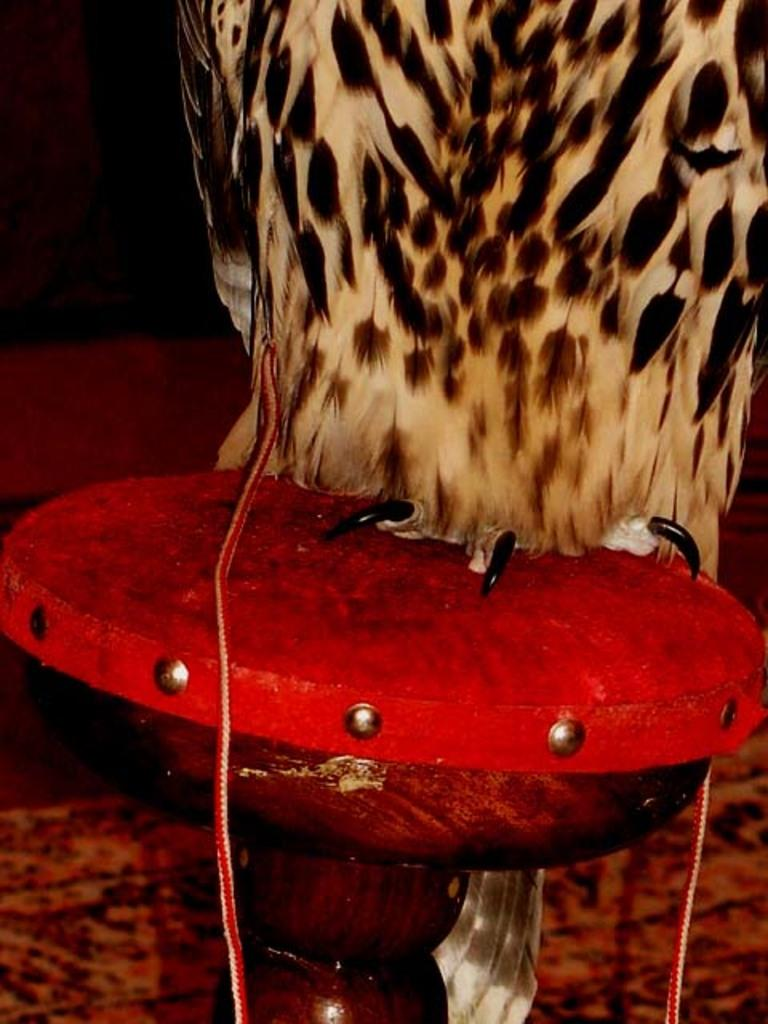What type of animal can be seen in the image? There is a bird in the image. Where is the bird located? The bird is on a stool. What can be observed about the background of the image? The background of the image is dark. How many dust particles can be seen on the bird in the image? There is no mention of dust particles in the image, so it is impossible to determine their number. 